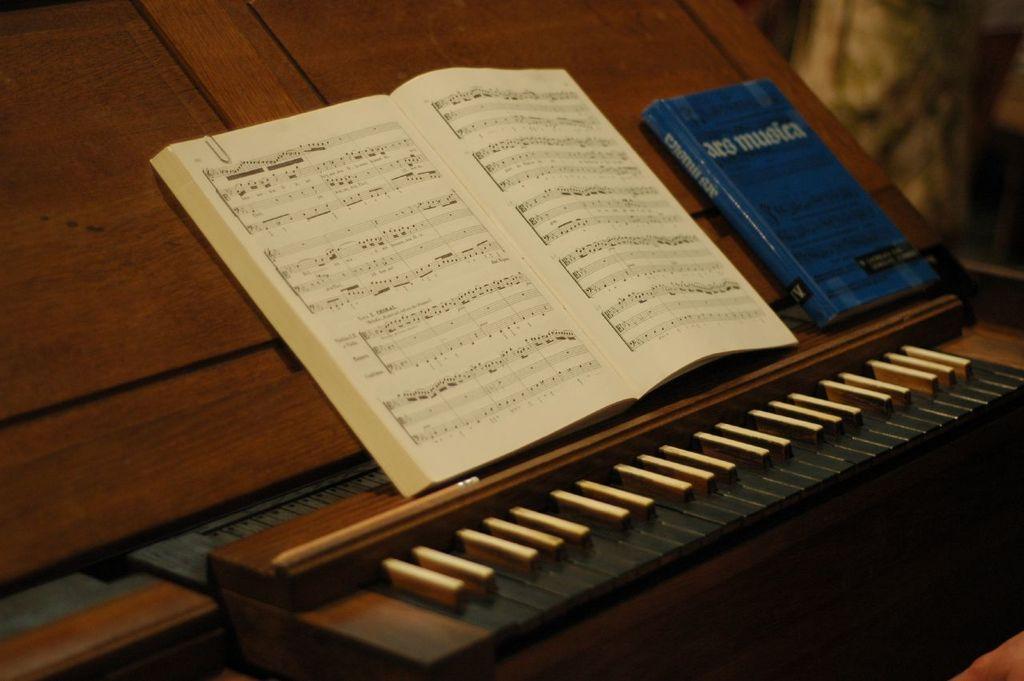Please provide a concise description of this image. In this picture placed on the top of a piano and a blue color book is to the right of the image. 